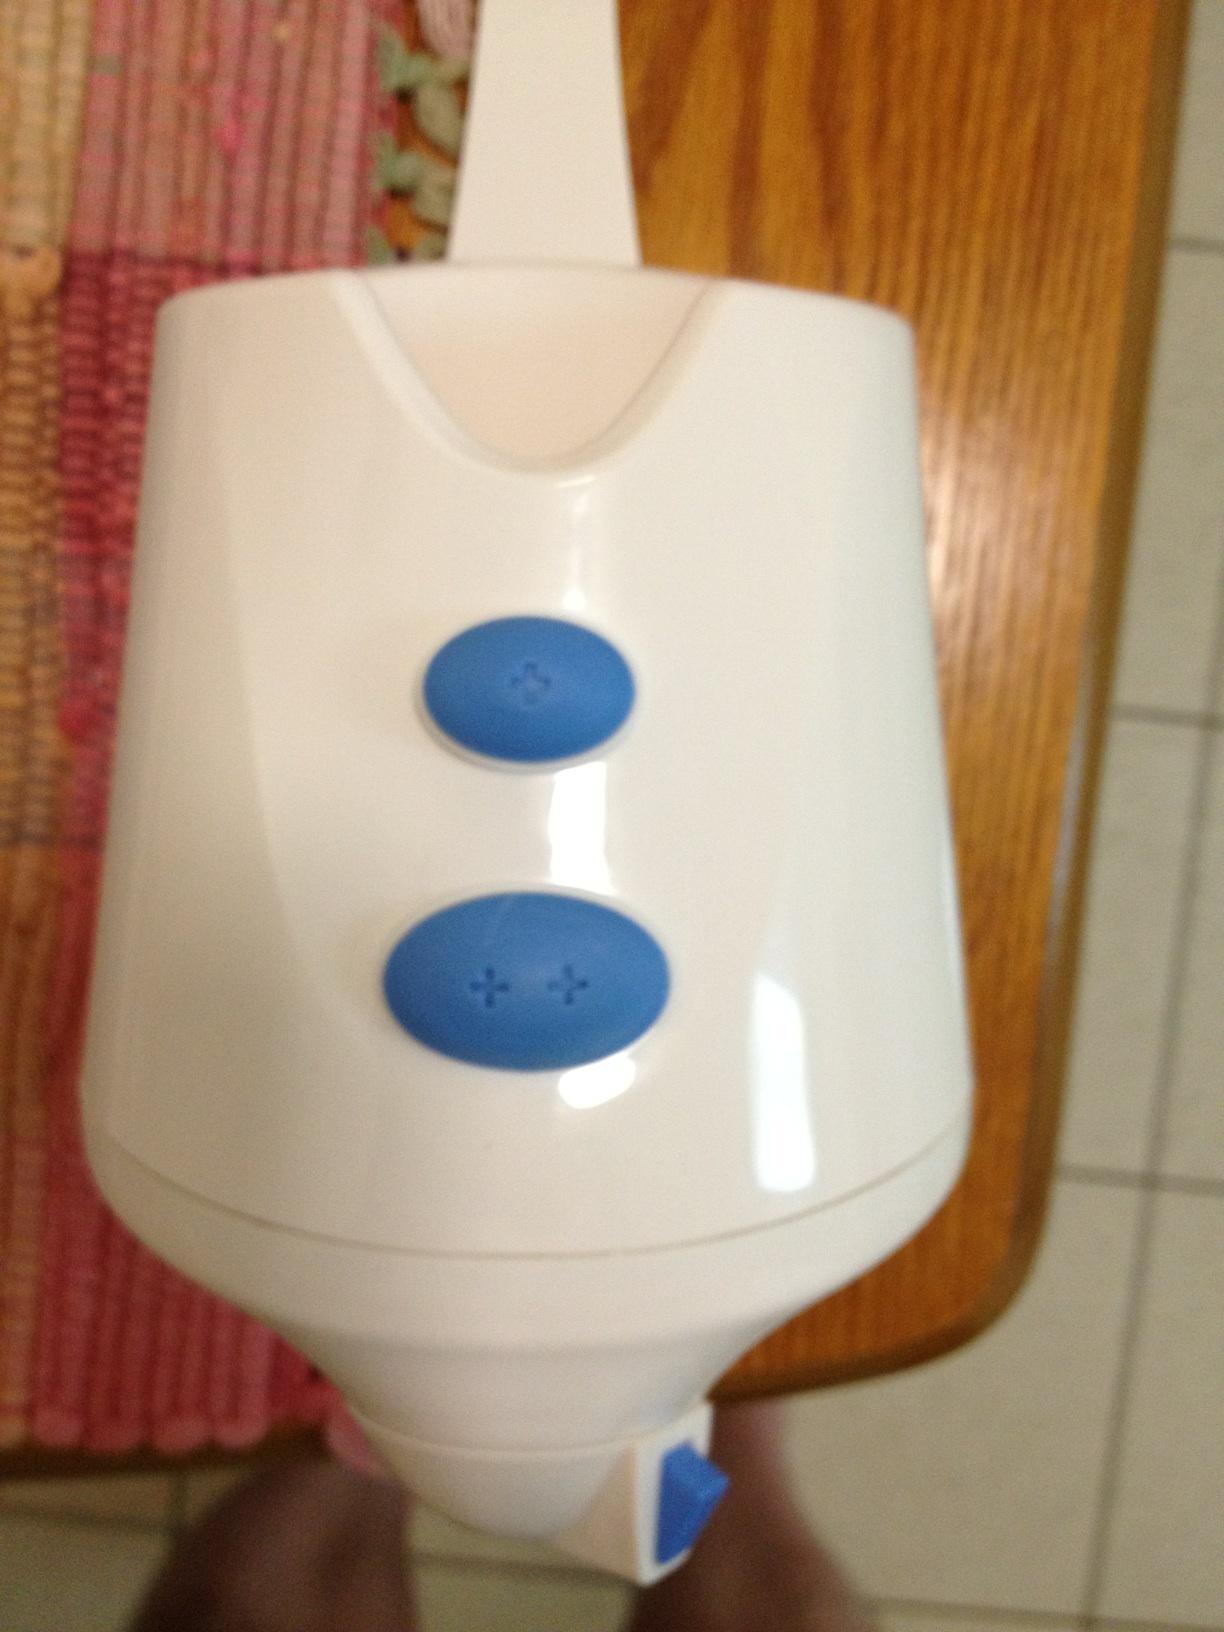Provide a realistic short scenario where this device is being used. In a busy household, this device is part of the morning routine. A family member uses it to quickly blend their morning smoothie, adjusting the intensity with the buttons to get the perfect consistency before heading off to work or school. 